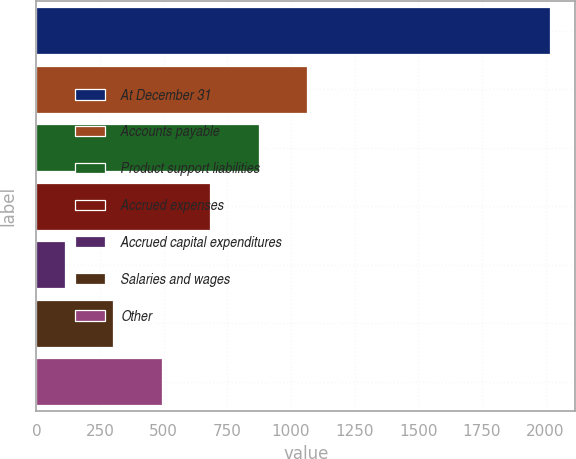Convert chart to OTSL. <chart><loc_0><loc_0><loc_500><loc_500><bar_chart><fcel>At December 31<fcel>Accounts payable<fcel>Product support liabilities<fcel>Accrued expenses<fcel>Accrued capital expenditures<fcel>Salaries and wages<fcel>Other<nl><fcel>2016<fcel>1063.6<fcel>873.12<fcel>682.64<fcel>111.2<fcel>301.68<fcel>492.16<nl></chart> 